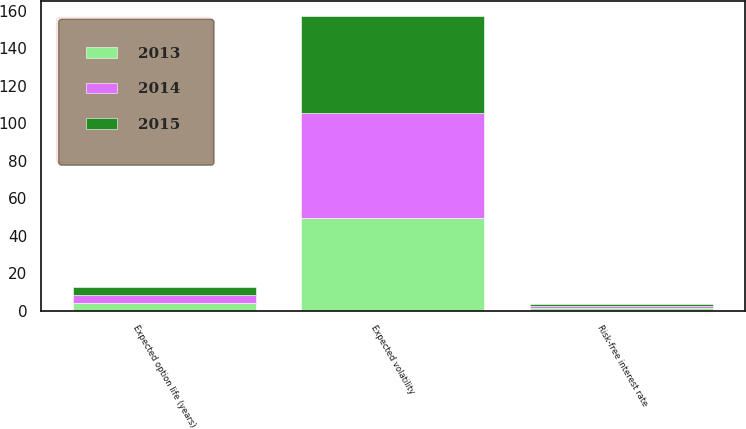<chart> <loc_0><loc_0><loc_500><loc_500><stacked_bar_chart><ecel><fcel>Risk-free interest rate<fcel>Expected option life (years)<fcel>Expected volatility<nl><fcel>2013<fcel>1.6<fcel>4.19<fcel>49.3<nl><fcel>2015<fcel>0.94<fcel>4.25<fcel>51.7<nl><fcel>2014<fcel>0.78<fcel>4.31<fcel>56.2<nl></chart> 